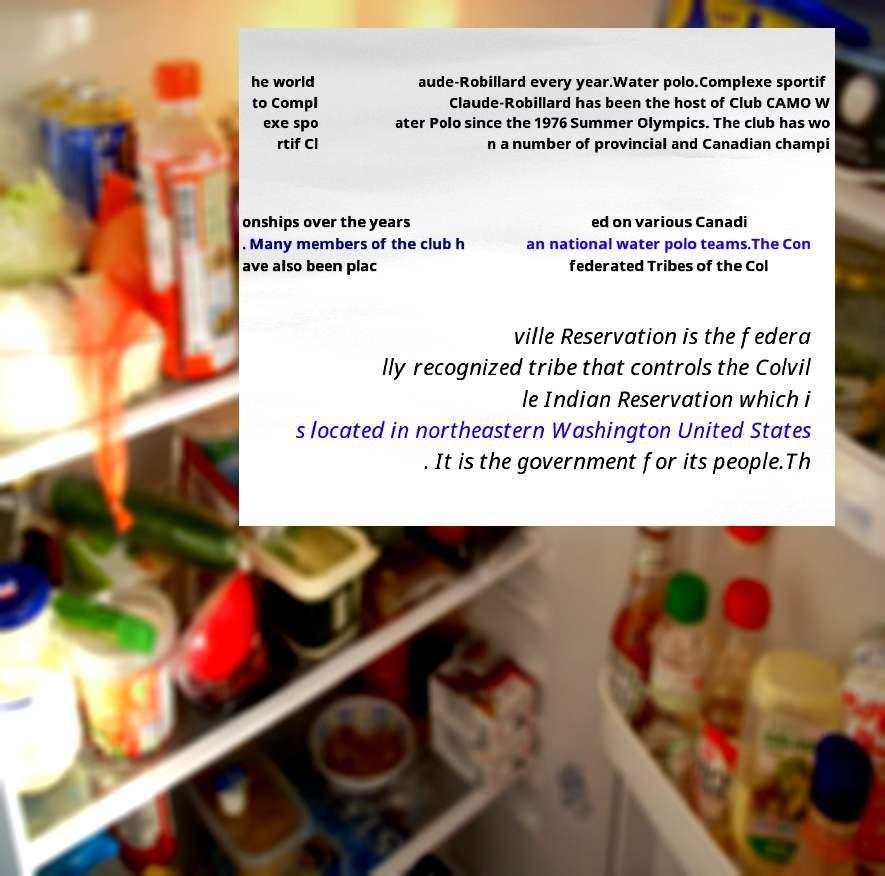Please identify and transcribe the text found in this image. he world to Compl exe spo rtif Cl aude-Robillard every year.Water polo.Complexe sportif Claude-Robillard has been the host of Club CAMO W ater Polo since the 1976 Summer Olympics. The club has wo n a number of provincial and Canadian champi onships over the years . Many members of the club h ave also been plac ed on various Canadi an national water polo teams.The Con federated Tribes of the Col ville Reservation is the federa lly recognized tribe that controls the Colvil le Indian Reservation which i s located in northeastern Washington United States . It is the government for its people.Th 